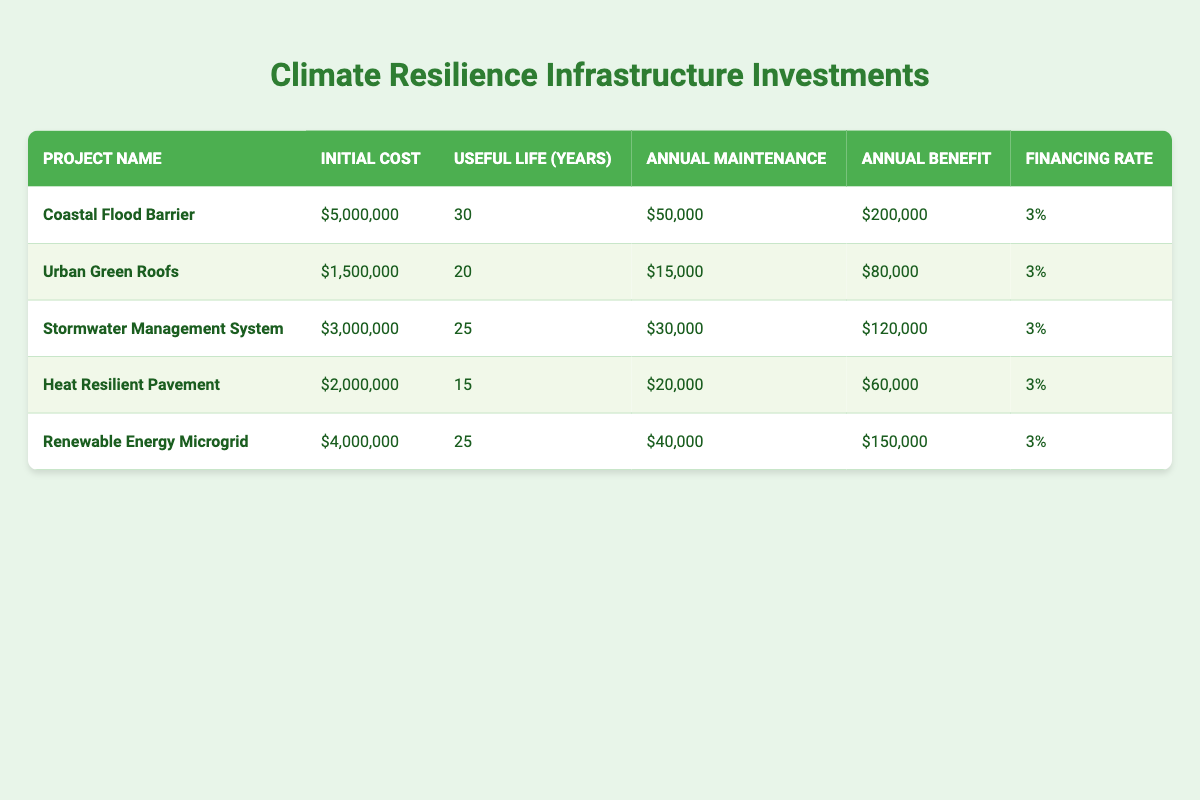What is the initial cost of the Coastal Flood Barrier project? The initial cost is explicitly listed in the table for the Coastal Flood Barrier project under the "Initial Cost" column. It states that the initial cost is 5,000,000.
Answer: 5,000,000 How many years is the useful life of the Urban Green Roofs? The useful life of the Urban Green Roofs is provided in the relevant column of the table. It is stated as 20 years.
Answer: 20 years What is the total annual maintenance cost for all projects combined? To find the total, we sum the annual maintenance costs: 50,000 (Coastal Flood Barrier) + 15,000 (Urban Green Roofs) + 30,000 (Stormwater Management System) + 20,000 (Heat Resilient Pavement) + 40,000 (Renewable Energy Microgrid) = 155,000.
Answer: 155,000 Is the annual benefit of the Stormwater Management System greater than 100,000? The annual benefit for the Stormwater Management System is listed as 120,000, which is indeed greater than 100,000. Therefore, this statement is true.
Answer: Yes What is the average initial cost of the projects listed? To find the average, first sum the initial costs: 5,000,000 + 1,500,000 + 3,000,000 + 2,000,000 + 4,000,000 = 15,500,000. Then, divide this by the number of projects (5): 15,500,000 / 5 = 3,100,000.
Answer: 3,100,000 Which project has the highest annual benefit, and what is that benefit? By examining the "Annual Benefit" column, we find the highest value, which corresponds to the Coastal Flood Barrier at 200,000. Thus, the Coastal Flood Barrier has the highest annual benefit of 200,000.
Answer: Coastal Flood Barrier, 200,000 What is the difference between the useful life of Heat Resilient Pavement and Stormwater Management System? The useful life of Heat Resilient Pavement is 15 years, and for the Stormwater Management System, it is 25 years. The difference is calculated as 25 - 15 = 10 years.
Answer: 10 years Does the Renewable Energy Microgrid project have a lower annual maintenance cost than the Coastal Flood Barrier? The annual maintenance cost for the Renewable Energy Microgrid is 40,000 while that for the Coastal Flood Barrier is 50,000. Since 40,000 is less than 50,000, this statement is true.
Answer: Yes What is the total annual benefit of the projects with a useful life of 25 years? The projects with a useful life of 25 years are the Stormwater Management System and the Renewable Energy Microgrid. Their annual benefits are 120,000 and 150,000, respectively. Summing these gives: 120,000 + 150,000 = 270,000.
Answer: 270,000 